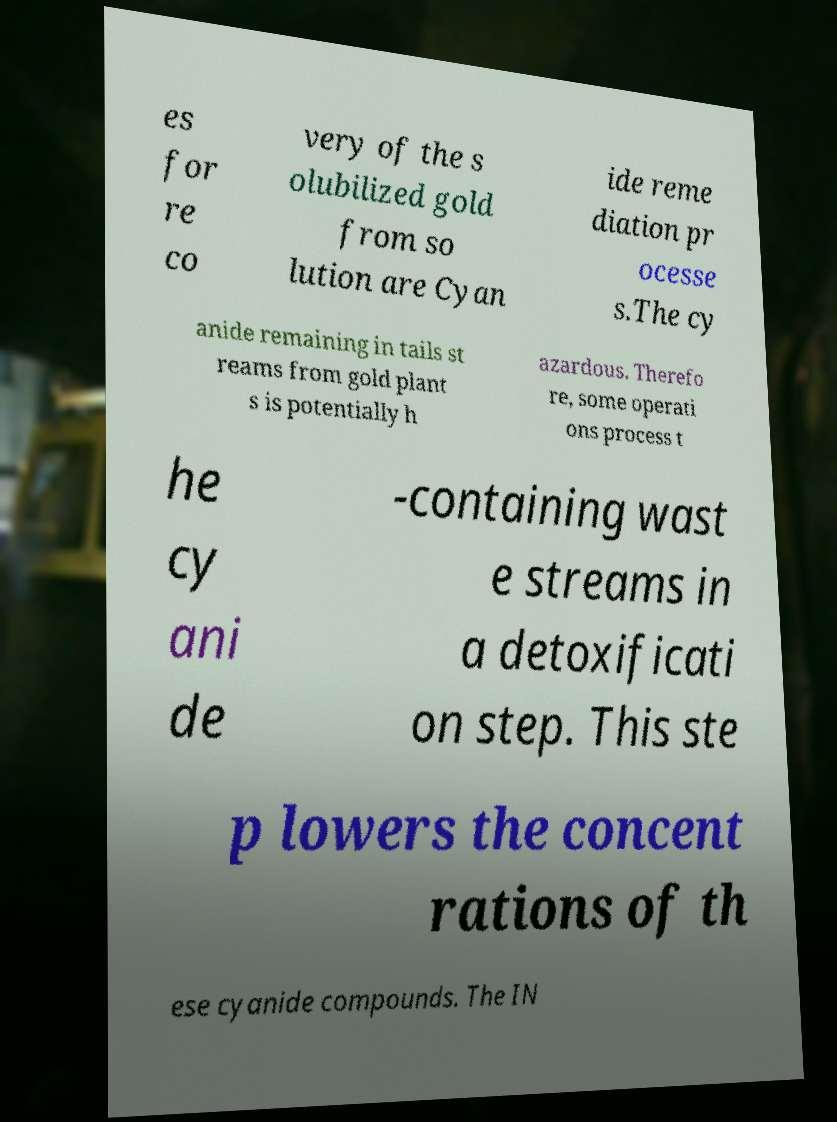What messages or text are displayed in this image? I need them in a readable, typed format. es for re co very of the s olubilized gold from so lution are Cyan ide reme diation pr ocesse s.The cy anide remaining in tails st reams from gold plant s is potentially h azardous. Therefo re, some operati ons process t he cy ani de -containing wast e streams in a detoxificati on step. This ste p lowers the concent rations of th ese cyanide compounds. The IN 